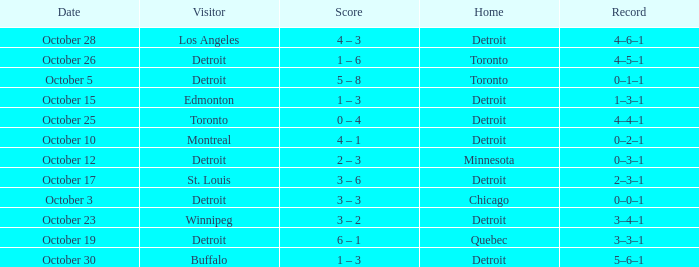Name the home with toronto visiting Detroit. 